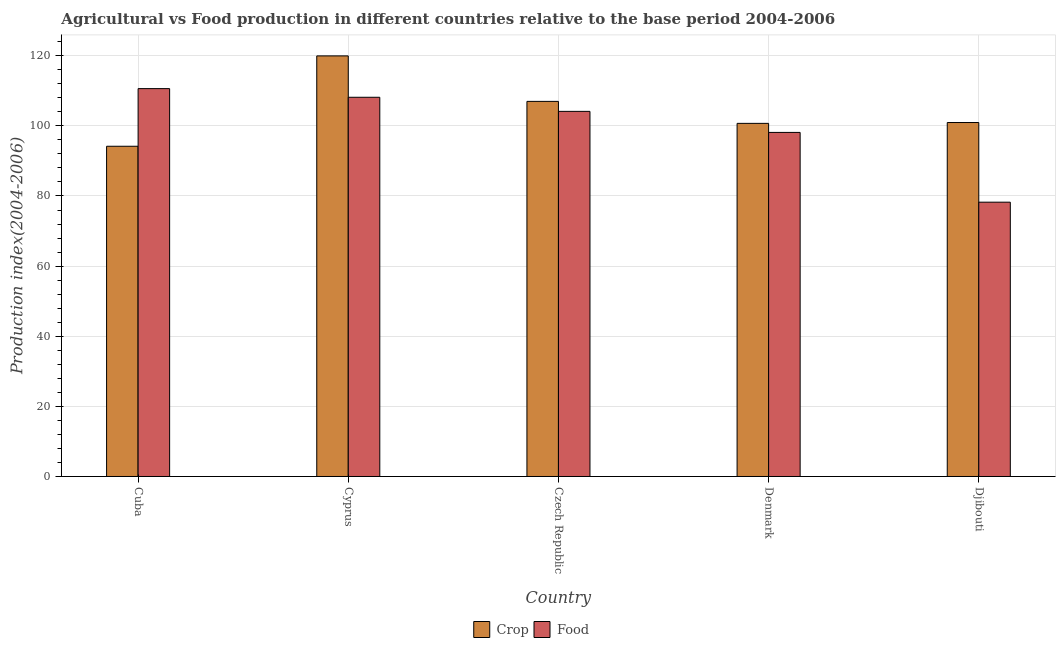How many different coloured bars are there?
Ensure brevity in your answer.  2. How many groups of bars are there?
Your answer should be very brief. 5. How many bars are there on the 4th tick from the left?
Keep it short and to the point. 2. What is the label of the 3rd group of bars from the left?
Your answer should be compact. Czech Republic. What is the crop production index in Czech Republic?
Your response must be concise. 106.98. Across all countries, what is the maximum crop production index?
Offer a very short reply. 119.95. Across all countries, what is the minimum crop production index?
Provide a succinct answer. 94.18. In which country was the food production index maximum?
Your answer should be compact. Cuba. In which country was the food production index minimum?
Offer a terse response. Djibouti. What is the total crop production index in the graph?
Offer a very short reply. 522.77. What is the difference between the food production index in Cyprus and that in Czech Republic?
Provide a short and direct response. 4.02. What is the difference between the crop production index in Denmark and the food production index in Djibouti?
Keep it short and to the point. 22.48. What is the average food production index per country?
Offer a very short reply. 99.85. What is the difference between the crop production index and food production index in Djibouti?
Your answer should be compact. 22.72. What is the ratio of the crop production index in Czech Republic to that in Denmark?
Give a very brief answer. 1.06. Is the difference between the food production index in Denmark and Djibouti greater than the difference between the crop production index in Denmark and Djibouti?
Give a very brief answer. Yes. What is the difference between the highest and the second highest food production index?
Make the answer very short. 2.47. What is the difference between the highest and the lowest food production index?
Your answer should be compact. 32.39. In how many countries, is the crop production index greater than the average crop production index taken over all countries?
Your answer should be compact. 2. Is the sum of the crop production index in Cuba and Djibouti greater than the maximum food production index across all countries?
Make the answer very short. Yes. What does the 2nd bar from the left in Cuba represents?
Make the answer very short. Food. What does the 2nd bar from the right in Djibouti represents?
Offer a very short reply. Crop. How many bars are there?
Offer a very short reply. 10. Are all the bars in the graph horizontal?
Provide a short and direct response. No. How many countries are there in the graph?
Give a very brief answer. 5. What is the difference between two consecutive major ticks on the Y-axis?
Offer a very short reply. 20. Are the values on the major ticks of Y-axis written in scientific E-notation?
Ensure brevity in your answer.  No. How are the legend labels stacked?
Your answer should be very brief. Horizontal. What is the title of the graph?
Give a very brief answer. Agricultural vs Food production in different countries relative to the base period 2004-2006. Does "Time to import" appear as one of the legend labels in the graph?
Ensure brevity in your answer.  No. What is the label or title of the X-axis?
Keep it short and to the point. Country. What is the label or title of the Y-axis?
Provide a short and direct response. Production index(2004-2006). What is the Production index(2004-2006) of Crop in Cuba?
Provide a short and direct response. 94.18. What is the Production index(2004-2006) of Food in Cuba?
Provide a succinct answer. 110.62. What is the Production index(2004-2006) of Crop in Cyprus?
Keep it short and to the point. 119.95. What is the Production index(2004-2006) in Food in Cyprus?
Offer a terse response. 108.15. What is the Production index(2004-2006) in Crop in Czech Republic?
Your answer should be compact. 106.98. What is the Production index(2004-2006) of Food in Czech Republic?
Ensure brevity in your answer.  104.13. What is the Production index(2004-2006) in Crop in Denmark?
Provide a short and direct response. 100.71. What is the Production index(2004-2006) of Food in Denmark?
Provide a succinct answer. 98.13. What is the Production index(2004-2006) of Crop in Djibouti?
Offer a very short reply. 100.95. What is the Production index(2004-2006) of Food in Djibouti?
Your answer should be very brief. 78.23. Across all countries, what is the maximum Production index(2004-2006) of Crop?
Keep it short and to the point. 119.95. Across all countries, what is the maximum Production index(2004-2006) in Food?
Make the answer very short. 110.62. Across all countries, what is the minimum Production index(2004-2006) of Crop?
Offer a terse response. 94.18. Across all countries, what is the minimum Production index(2004-2006) in Food?
Give a very brief answer. 78.23. What is the total Production index(2004-2006) in Crop in the graph?
Provide a short and direct response. 522.77. What is the total Production index(2004-2006) in Food in the graph?
Ensure brevity in your answer.  499.26. What is the difference between the Production index(2004-2006) in Crop in Cuba and that in Cyprus?
Offer a terse response. -25.77. What is the difference between the Production index(2004-2006) in Food in Cuba and that in Cyprus?
Make the answer very short. 2.47. What is the difference between the Production index(2004-2006) of Crop in Cuba and that in Czech Republic?
Your response must be concise. -12.8. What is the difference between the Production index(2004-2006) in Food in Cuba and that in Czech Republic?
Your answer should be compact. 6.49. What is the difference between the Production index(2004-2006) in Crop in Cuba and that in Denmark?
Offer a very short reply. -6.53. What is the difference between the Production index(2004-2006) of Food in Cuba and that in Denmark?
Your answer should be compact. 12.49. What is the difference between the Production index(2004-2006) of Crop in Cuba and that in Djibouti?
Make the answer very short. -6.77. What is the difference between the Production index(2004-2006) of Food in Cuba and that in Djibouti?
Offer a terse response. 32.39. What is the difference between the Production index(2004-2006) of Crop in Cyprus and that in Czech Republic?
Give a very brief answer. 12.97. What is the difference between the Production index(2004-2006) of Food in Cyprus and that in Czech Republic?
Your answer should be very brief. 4.02. What is the difference between the Production index(2004-2006) of Crop in Cyprus and that in Denmark?
Your answer should be very brief. 19.24. What is the difference between the Production index(2004-2006) in Food in Cyprus and that in Denmark?
Your answer should be very brief. 10.02. What is the difference between the Production index(2004-2006) of Food in Cyprus and that in Djibouti?
Your answer should be very brief. 29.92. What is the difference between the Production index(2004-2006) of Crop in Czech Republic and that in Denmark?
Ensure brevity in your answer.  6.27. What is the difference between the Production index(2004-2006) in Crop in Czech Republic and that in Djibouti?
Offer a terse response. 6.03. What is the difference between the Production index(2004-2006) of Food in Czech Republic and that in Djibouti?
Your answer should be compact. 25.9. What is the difference between the Production index(2004-2006) in Crop in Denmark and that in Djibouti?
Make the answer very short. -0.24. What is the difference between the Production index(2004-2006) of Crop in Cuba and the Production index(2004-2006) of Food in Cyprus?
Provide a succinct answer. -13.97. What is the difference between the Production index(2004-2006) in Crop in Cuba and the Production index(2004-2006) in Food in Czech Republic?
Provide a short and direct response. -9.95. What is the difference between the Production index(2004-2006) of Crop in Cuba and the Production index(2004-2006) of Food in Denmark?
Your response must be concise. -3.95. What is the difference between the Production index(2004-2006) in Crop in Cuba and the Production index(2004-2006) in Food in Djibouti?
Make the answer very short. 15.95. What is the difference between the Production index(2004-2006) in Crop in Cyprus and the Production index(2004-2006) in Food in Czech Republic?
Give a very brief answer. 15.82. What is the difference between the Production index(2004-2006) in Crop in Cyprus and the Production index(2004-2006) in Food in Denmark?
Offer a very short reply. 21.82. What is the difference between the Production index(2004-2006) in Crop in Cyprus and the Production index(2004-2006) in Food in Djibouti?
Offer a terse response. 41.72. What is the difference between the Production index(2004-2006) of Crop in Czech Republic and the Production index(2004-2006) of Food in Denmark?
Ensure brevity in your answer.  8.85. What is the difference between the Production index(2004-2006) of Crop in Czech Republic and the Production index(2004-2006) of Food in Djibouti?
Keep it short and to the point. 28.75. What is the difference between the Production index(2004-2006) of Crop in Denmark and the Production index(2004-2006) of Food in Djibouti?
Offer a terse response. 22.48. What is the average Production index(2004-2006) of Crop per country?
Provide a succinct answer. 104.55. What is the average Production index(2004-2006) in Food per country?
Offer a terse response. 99.85. What is the difference between the Production index(2004-2006) in Crop and Production index(2004-2006) in Food in Cuba?
Make the answer very short. -16.44. What is the difference between the Production index(2004-2006) in Crop and Production index(2004-2006) in Food in Cyprus?
Your answer should be compact. 11.8. What is the difference between the Production index(2004-2006) of Crop and Production index(2004-2006) of Food in Czech Republic?
Ensure brevity in your answer.  2.85. What is the difference between the Production index(2004-2006) of Crop and Production index(2004-2006) of Food in Denmark?
Your answer should be very brief. 2.58. What is the difference between the Production index(2004-2006) of Crop and Production index(2004-2006) of Food in Djibouti?
Provide a succinct answer. 22.72. What is the ratio of the Production index(2004-2006) in Crop in Cuba to that in Cyprus?
Give a very brief answer. 0.79. What is the ratio of the Production index(2004-2006) in Food in Cuba to that in Cyprus?
Your response must be concise. 1.02. What is the ratio of the Production index(2004-2006) of Crop in Cuba to that in Czech Republic?
Your answer should be compact. 0.88. What is the ratio of the Production index(2004-2006) in Food in Cuba to that in Czech Republic?
Keep it short and to the point. 1.06. What is the ratio of the Production index(2004-2006) of Crop in Cuba to that in Denmark?
Provide a short and direct response. 0.94. What is the ratio of the Production index(2004-2006) of Food in Cuba to that in Denmark?
Offer a very short reply. 1.13. What is the ratio of the Production index(2004-2006) of Crop in Cuba to that in Djibouti?
Give a very brief answer. 0.93. What is the ratio of the Production index(2004-2006) of Food in Cuba to that in Djibouti?
Keep it short and to the point. 1.41. What is the ratio of the Production index(2004-2006) of Crop in Cyprus to that in Czech Republic?
Provide a succinct answer. 1.12. What is the ratio of the Production index(2004-2006) in Food in Cyprus to that in Czech Republic?
Your answer should be very brief. 1.04. What is the ratio of the Production index(2004-2006) in Crop in Cyprus to that in Denmark?
Your answer should be compact. 1.19. What is the ratio of the Production index(2004-2006) in Food in Cyprus to that in Denmark?
Offer a terse response. 1.1. What is the ratio of the Production index(2004-2006) of Crop in Cyprus to that in Djibouti?
Provide a short and direct response. 1.19. What is the ratio of the Production index(2004-2006) in Food in Cyprus to that in Djibouti?
Offer a very short reply. 1.38. What is the ratio of the Production index(2004-2006) in Crop in Czech Republic to that in Denmark?
Offer a very short reply. 1.06. What is the ratio of the Production index(2004-2006) of Food in Czech Republic to that in Denmark?
Ensure brevity in your answer.  1.06. What is the ratio of the Production index(2004-2006) in Crop in Czech Republic to that in Djibouti?
Keep it short and to the point. 1.06. What is the ratio of the Production index(2004-2006) in Food in Czech Republic to that in Djibouti?
Your answer should be compact. 1.33. What is the ratio of the Production index(2004-2006) in Crop in Denmark to that in Djibouti?
Keep it short and to the point. 1. What is the ratio of the Production index(2004-2006) in Food in Denmark to that in Djibouti?
Your answer should be very brief. 1.25. What is the difference between the highest and the second highest Production index(2004-2006) in Crop?
Your answer should be very brief. 12.97. What is the difference between the highest and the second highest Production index(2004-2006) in Food?
Give a very brief answer. 2.47. What is the difference between the highest and the lowest Production index(2004-2006) in Crop?
Provide a short and direct response. 25.77. What is the difference between the highest and the lowest Production index(2004-2006) of Food?
Keep it short and to the point. 32.39. 